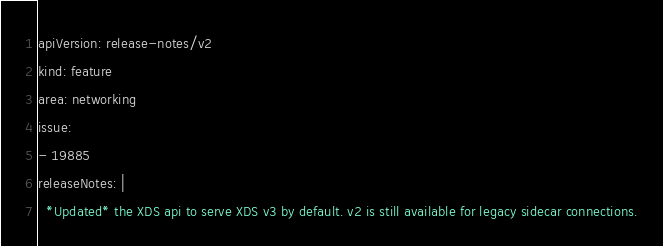Convert code to text. <code><loc_0><loc_0><loc_500><loc_500><_YAML_>apiVersion: release-notes/v2
kind: feature
area: networking
issue:
- 19885
releaseNotes: |
  *Updated* the XDS api to serve XDS v3 by default. v2 is still available for legacy sidecar connections.
</code> 